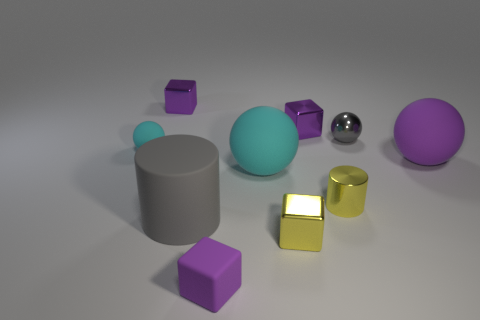What number of gray rubber objects are there?
Your answer should be compact. 1. Is the number of small things in front of the purple rubber ball less than the number of matte cylinders in front of the large matte cylinder?
Your answer should be very brief. No. Are there fewer small balls to the left of the large cyan rubber ball than gray rubber cubes?
Ensure brevity in your answer.  No. The sphere that is behind the tiny matte object behind the small shiny block that is in front of the purple matte ball is made of what material?
Give a very brief answer. Metal. How many things are rubber balls that are left of the large purple matte ball or objects left of the big rubber cylinder?
Provide a succinct answer. 3. What is the material of the yellow object that is the same shape as the small purple matte object?
Provide a succinct answer. Metal. How many rubber objects are either large yellow objects or purple objects?
Keep it short and to the point. 2. What shape is the small cyan object that is made of the same material as the big cyan object?
Offer a very short reply. Sphere. How many cyan matte objects have the same shape as the small gray shiny thing?
Keep it short and to the point. 2. There is a cyan object that is right of the small rubber sphere; is it the same shape as the small matte thing that is in front of the tiny cyan thing?
Offer a terse response. No. 